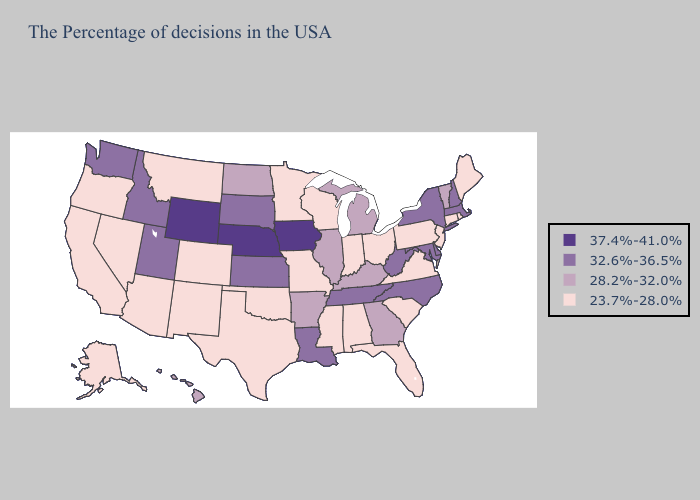Does Washington have the highest value in the USA?
Write a very short answer. No. Among the states that border Kansas , does Nebraska have the highest value?
Quick response, please. Yes. Does North Dakota have the highest value in the USA?
Give a very brief answer. No. Does Oklahoma have the same value as Ohio?
Give a very brief answer. Yes. Name the states that have a value in the range 32.6%-36.5%?
Be succinct. Massachusetts, New Hampshire, New York, Delaware, Maryland, North Carolina, West Virginia, Tennessee, Louisiana, Kansas, South Dakota, Utah, Idaho, Washington. Name the states that have a value in the range 37.4%-41.0%?
Write a very short answer. Iowa, Nebraska, Wyoming. Name the states that have a value in the range 32.6%-36.5%?
Quick response, please. Massachusetts, New Hampshire, New York, Delaware, Maryland, North Carolina, West Virginia, Tennessee, Louisiana, Kansas, South Dakota, Utah, Idaho, Washington. What is the value of Alabama?
Concise answer only. 23.7%-28.0%. Which states have the lowest value in the USA?
Be succinct. Maine, Rhode Island, Connecticut, New Jersey, Pennsylvania, Virginia, South Carolina, Ohio, Florida, Indiana, Alabama, Wisconsin, Mississippi, Missouri, Minnesota, Oklahoma, Texas, Colorado, New Mexico, Montana, Arizona, Nevada, California, Oregon, Alaska. What is the lowest value in the MidWest?
Quick response, please. 23.7%-28.0%. Which states have the lowest value in the USA?
Concise answer only. Maine, Rhode Island, Connecticut, New Jersey, Pennsylvania, Virginia, South Carolina, Ohio, Florida, Indiana, Alabama, Wisconsin, Mississippi, Missouri, Minnesota, Oklahoma, Texas, Colorado, New Mexico, Montana, Arizona, Nevada, California, Oregon, Alaska. What is the value of Connecticut?
Answer briefly. 23.7%-28.0%. Among the states that border Kentucky , does West Virginia have the highest value?
Be succinct. Yes. What is the lowest value in the Northeast?
Short answer required. 23.7%-28.0%. Among the states that border Virginia , does Kentucky have the highest value?
Concise answer only. No. 